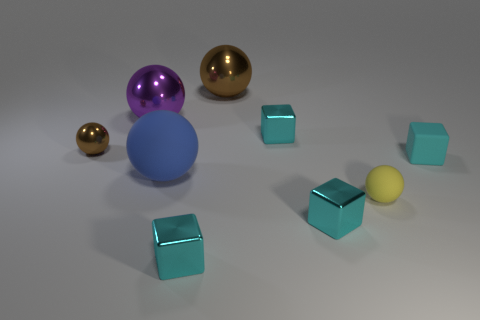Are there more brown metallic objects behind the tiny shiny ball than big objects that are behind the big blue rubber ball?
Give a very brief answer. No. How many other objects are there of the same size as the blue matte sphere?
Offer a very short reply. 2. How big is the cyan metallic object that is on the right side of the cyan metallic cube behind the tiny yellow sphere?
Your response must be concise. Small. How many small objects are either cyan metal things or yellow spheres?
Your answer should be very brief. 4. What size is the brown object in front of the big thing to the right of the big sphere in front of the small cyan rubber block?
Offer a very short reply. Small. Is there anything else that is the same color as the tiny matte cube?
Give a very brief answer. Yes. The small ball that is to the right of the brown object that is on the right side of the matte ball left of the tiny yellow sphere is made of what material?
Offer a very short reply. Rubber. Does the small cyan matte thing have the same shape as the tiny brown shiny thing?
Make the answer very short. No. Is there anything else that has the same material as the large brown thing?
Make the answer very short. Yes. How many shiny objects are both to the right of the big purple object and in front of the big purple metallic object?
Your answer should be very brief. 3. 